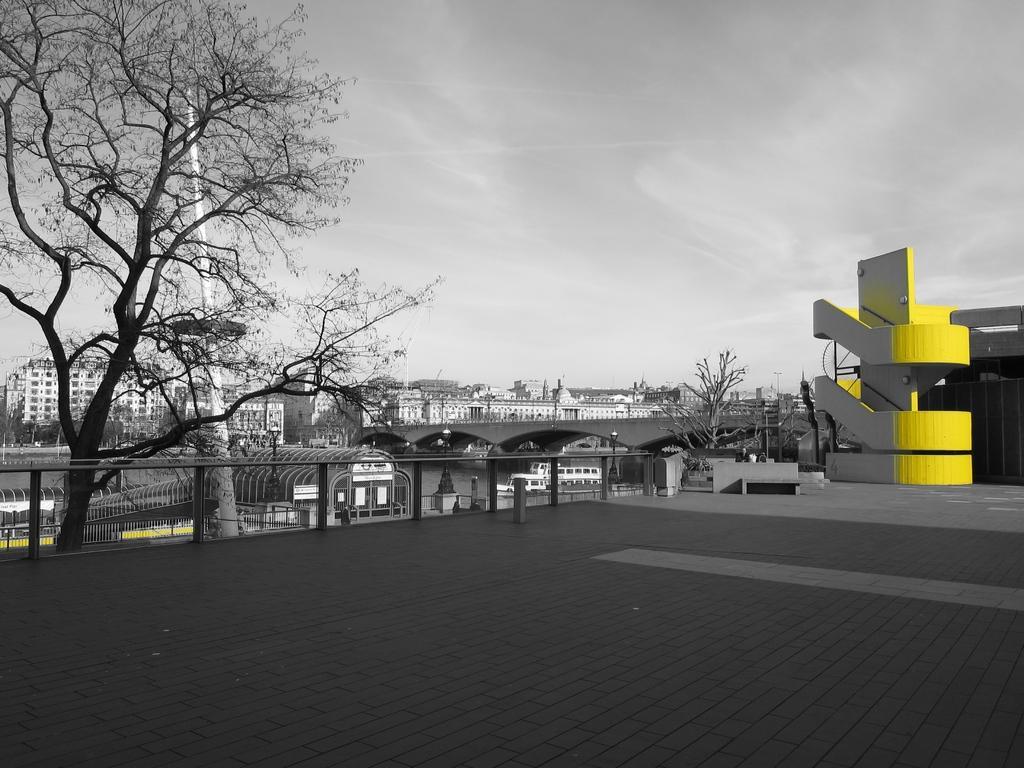Please provide a concise description of this image. It is an edited image. In this image we can see the buildings, trees, bridge, pole and also the fence. At the top there is sky and at the bottom we can see the path. 